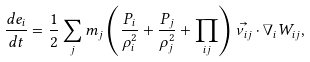<formula> <loc_0><loc_0><loc_500><loc_500>\frac { d e _ { i } } { d t } = \frac { 1 } { 2 } \sum _ { j } m _ { j } \left ( \frac { P _ { i } } { \rho _ { i } ^ { 2 } } + \frac { P _ { j } } { \rho _ { j } ^ { 2 } } + \prod _ { i j } \right ) \vec { \nu _ { i j } } \cdot \nabla _ { i } W _ { i j } ,</formula> 